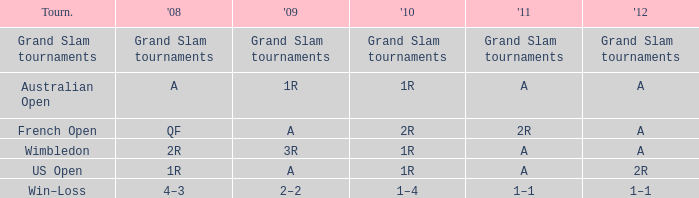Name the 2011 when 2010 is 2r 2R. 